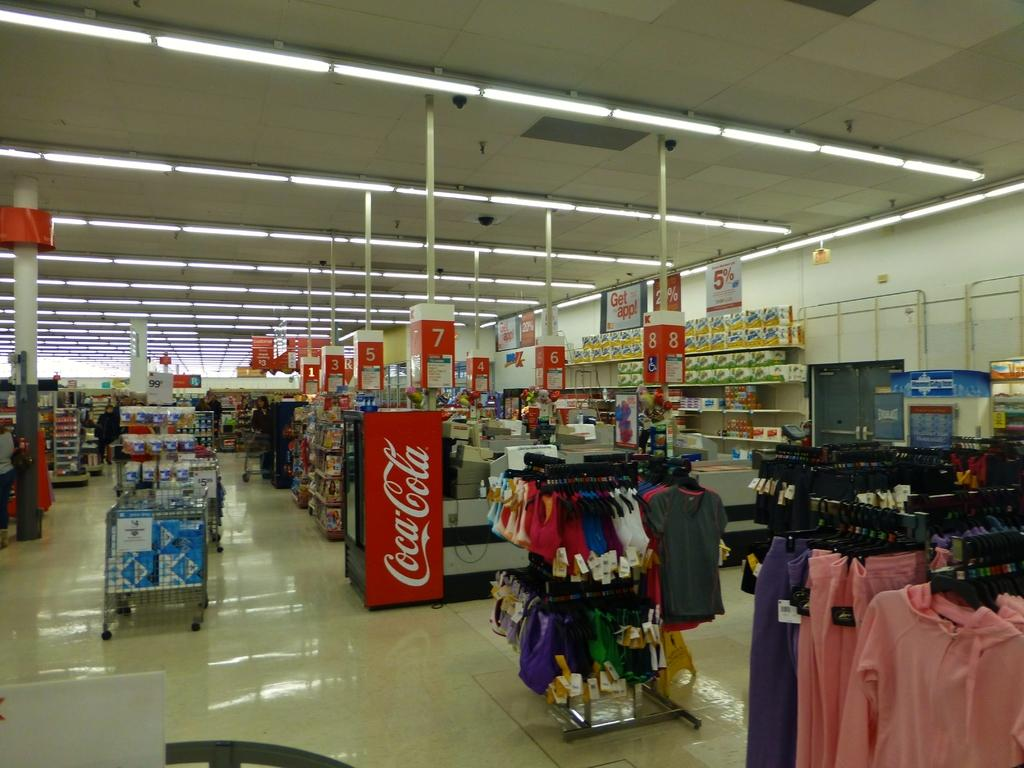<image>
Present a compact description of the photo's key features. In a department store is a cooler advertising coca cola. 